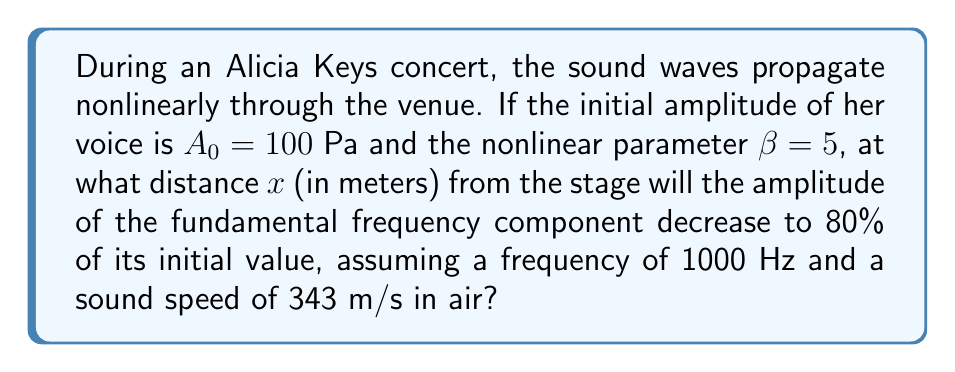Solve this math problem. To solve this problem, we need to use the nonlinear wave equation for sound propagation. The amplitude of the fundamental frequency component $A_1$ at a distance $x$ from the source is given by:

$$A_1(x) = \frac{A_0}{\sqrt{1 + (\beta \epsilon k x)^2}}$$

Where:
$A_0$ is the initial amplitude
$\beta$ is the nonlinear parameter
$\epsilon = \frac{A_0}{\rho c^2}$ is the acoustic Mach number
$\rho$ is the density of air (approximately 1.2 kg/m³)
$c$ is the speed of sound in air (given as 343 m/s)
$k = \frac{2\pi f}{c}$ is the wave number
$f$ is the frequency (given as 1000 Hz)

Step 1: Calculate the wave number $k$
$$k = \frac{2\pi f}{c} = \frac{2\pi \cdot 1000}{343} \approx 18.33 \text{ m}^{-1}$$

Step 2: Calculate the acoustic Mach number $\epsilon$
$$\epsilon = \frac{A_0}{\rho c^2} = \frac{100}{1.2 \cdot 343^2} \approx 7.11 \times 10^{-4}$$

Step 3: Set up the equation for 80% of the initial amplitude
$$0.8A_0 = \frac{A_0}{\sqrt{1 + (\beta \epsilon k x)^2}}$$

Step 4: Solve for $x$
$$0.8 = \frac{1}{\sqrt{1 + (\beta \epsilon k x)^2}}$$
$$\frac{1}{0.8^2} = 1 + (\beta \epsilon k x)^2$$
$$\frac{1}{0.8^2} - 1 = (\beta \epsilon k x)^2$$
$$x = \frac{\sqrt{\frac{1}{0.8^2} - 1}}{\beta \epsilon k}$$

Step 5: Calculate the final result
$$x = \frac{\sqrt{\frac{1}{0.8^2} - 1}}{5 \cdot 7.11 \times 10^{-4} \cdot 18.33} \approx 21.37 \text{ m}$$
Answer: 21.37 m 